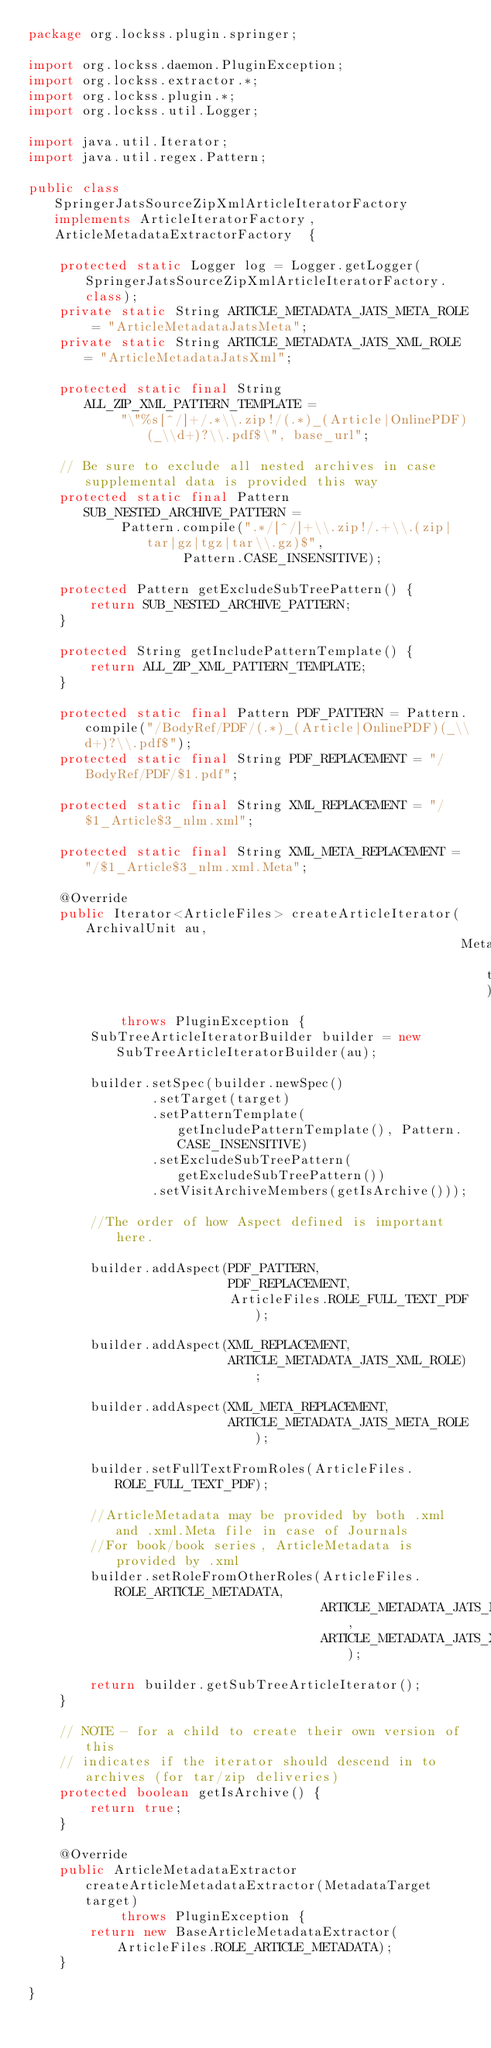Convert code to text. <code><loc_0><loc_0><loc_500><loc_500><_Java_>package org.lockss.plugin.springer;

import org.lockss.daemon.PluginException;
import org.lockss.extractor.*;
import org.lockss.plugin.*;
import org.lockss.util.Logger;

import java.util.Iterator;
import java.util.regex.Pattern;

public class SpringerJatsSourceZipXmlArticleIteratorFactory implements ArticleIteratorFactory, ArticleMetadataExtractorFactory  {

    protected static Logger log = Logger.getLogger(SpringerJatsSourceZipXmlArticleIteratorFactory.class);
    private static String ARTICLE_METADATA_JATS_META_ROLE = "ArticleMetadataJatsMeta";
    private static String ARTICLE_METADATA_JATS_XML_ROLE = "ArticleMetadataJatsXml";

    protected static final String ALL_ZIP_XML_PATTERN_TEMPLATE =
            "\"%s[^/]+/.*\\.zip!/(.*)_(Article|OnlinePDF)(_\\d+)?\\.pdf$\", base_url";

    // Be sure to exclude all nested archives in case supplemental data is provided this way
    protected static final Pattern SUB_NESTED_ARCHIVE_PATTERN =
            Pattern.compile(".*/[^/]+\\.zip!/.+\\.(zip|tar|gz|tgz|tar\\.gz)$",
                    Pattern.CASE_INSENSITIVE);

    protected Pattern getExcludeSubTreePattern() {
        return SUB_NESTED_ARCHIVE_PATTERN;
    }

    protected String getIncludePatternTemplate() {
        return ALL_ZIP_XML_PATTERN_TEMPLATE;
    }

    protected static final Pattern PDF_PATTERN = Pattern.compile("/BodyRef/PDF/(.*)_(Article|OnlinePDF)(_\\d+)?\\.pdf$");
    protected static final String PDF_REPLACEMENT = "/BodyRef/PDF/$1.pdf";

    protected static final String XML_REPLACEMENT = "/$1_Article$3_nlm.xml";

    protected static final String XML_META_REPLACEMENT = "/$1_Article$3_nlm.xml.Meta";

    @Override
    public Iterator<ArticleFiles> createArticleIterator(ArchivalUnit au,
                                                        MetadataTarget target)
            throws PluginException {
        SubTreeArticleIteratorBuilder builder = new SubTreeArticleIteratorBuilder(au);

        builder.setSpec(builder.newSpec()
                .setTarget(target)
                .setPatternTemplate(getIncludePatternTemplate(), Pattern.CASE_INSENSITIVE)
                .setExcludeSubTreePattern(getExcludeSubTreePattern())
                .setVisitArchiveMembers(getIsArchive()));

        //The order of how Aspect defined is important here.
        
        builder.addAspect(PDF_PATTERN,
                          PDF_REPLACEMENT,
                          ArticleFiles.ROLE_FULL_TEXT_PDF);

        builder.addAspect(XML_REPLACEMENT,
                          ARTICLE_METADATA_JATS_XML_ROLE);

        builder.addAspect(XML_META_REPLACEMENT,
                          ARTICLE_METADATA_JATS_META_ROLE);

        builder.setFullTextFromRoles(ArticleFiles.ROLE_FULL_TEXT_PDF);
        
        //ArticleMetadata may be provided by both .xml and .xml.Meta file in case of Journals
        //For book/book series, ArticleMetadata is provided by .xml
        builder.setRoleFromOtherRoles(ArticleFiles.ROLE_ARTICLE_METADATA,
                                      ARTICLE_METADATA_JATS_META_ROLE,
                                      ARTICLE_METADATA_JATS_XML_ROLE);

        return builder.getSubTreeArticleIterator();
    }

    // NOTE - for a child to create their own version of this
    // indicates if the iterator should descend in to archives (for tar/zip deliveries)
    protected boolean getIsArchive() {
        return true;
    }

    @Override
    public ArticleMetadataExtractor createArticleMetadataExtractor(MetadataTarget target)
            throws PluginException {
        return new BaseArticleMetadataExtractor(ArticleFiles.ROLE_ARTICLE_METADATA);
    }

}
</code> 